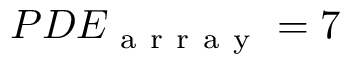<formula> <loc_0><loc_0><loc_500><loc_500>P D E _ { a r r a y } = 7 \</formula> 